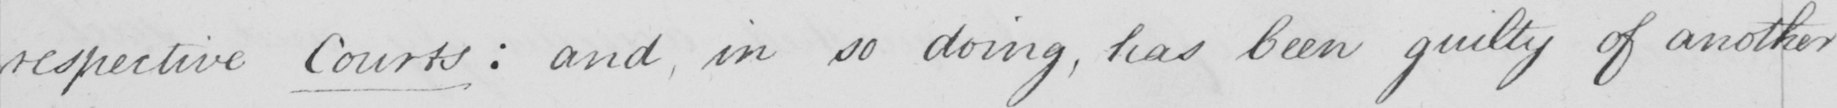Transcribe the text shown in this historical manuscript line. respective Courts :  and , in so doing , has been guilty of another 